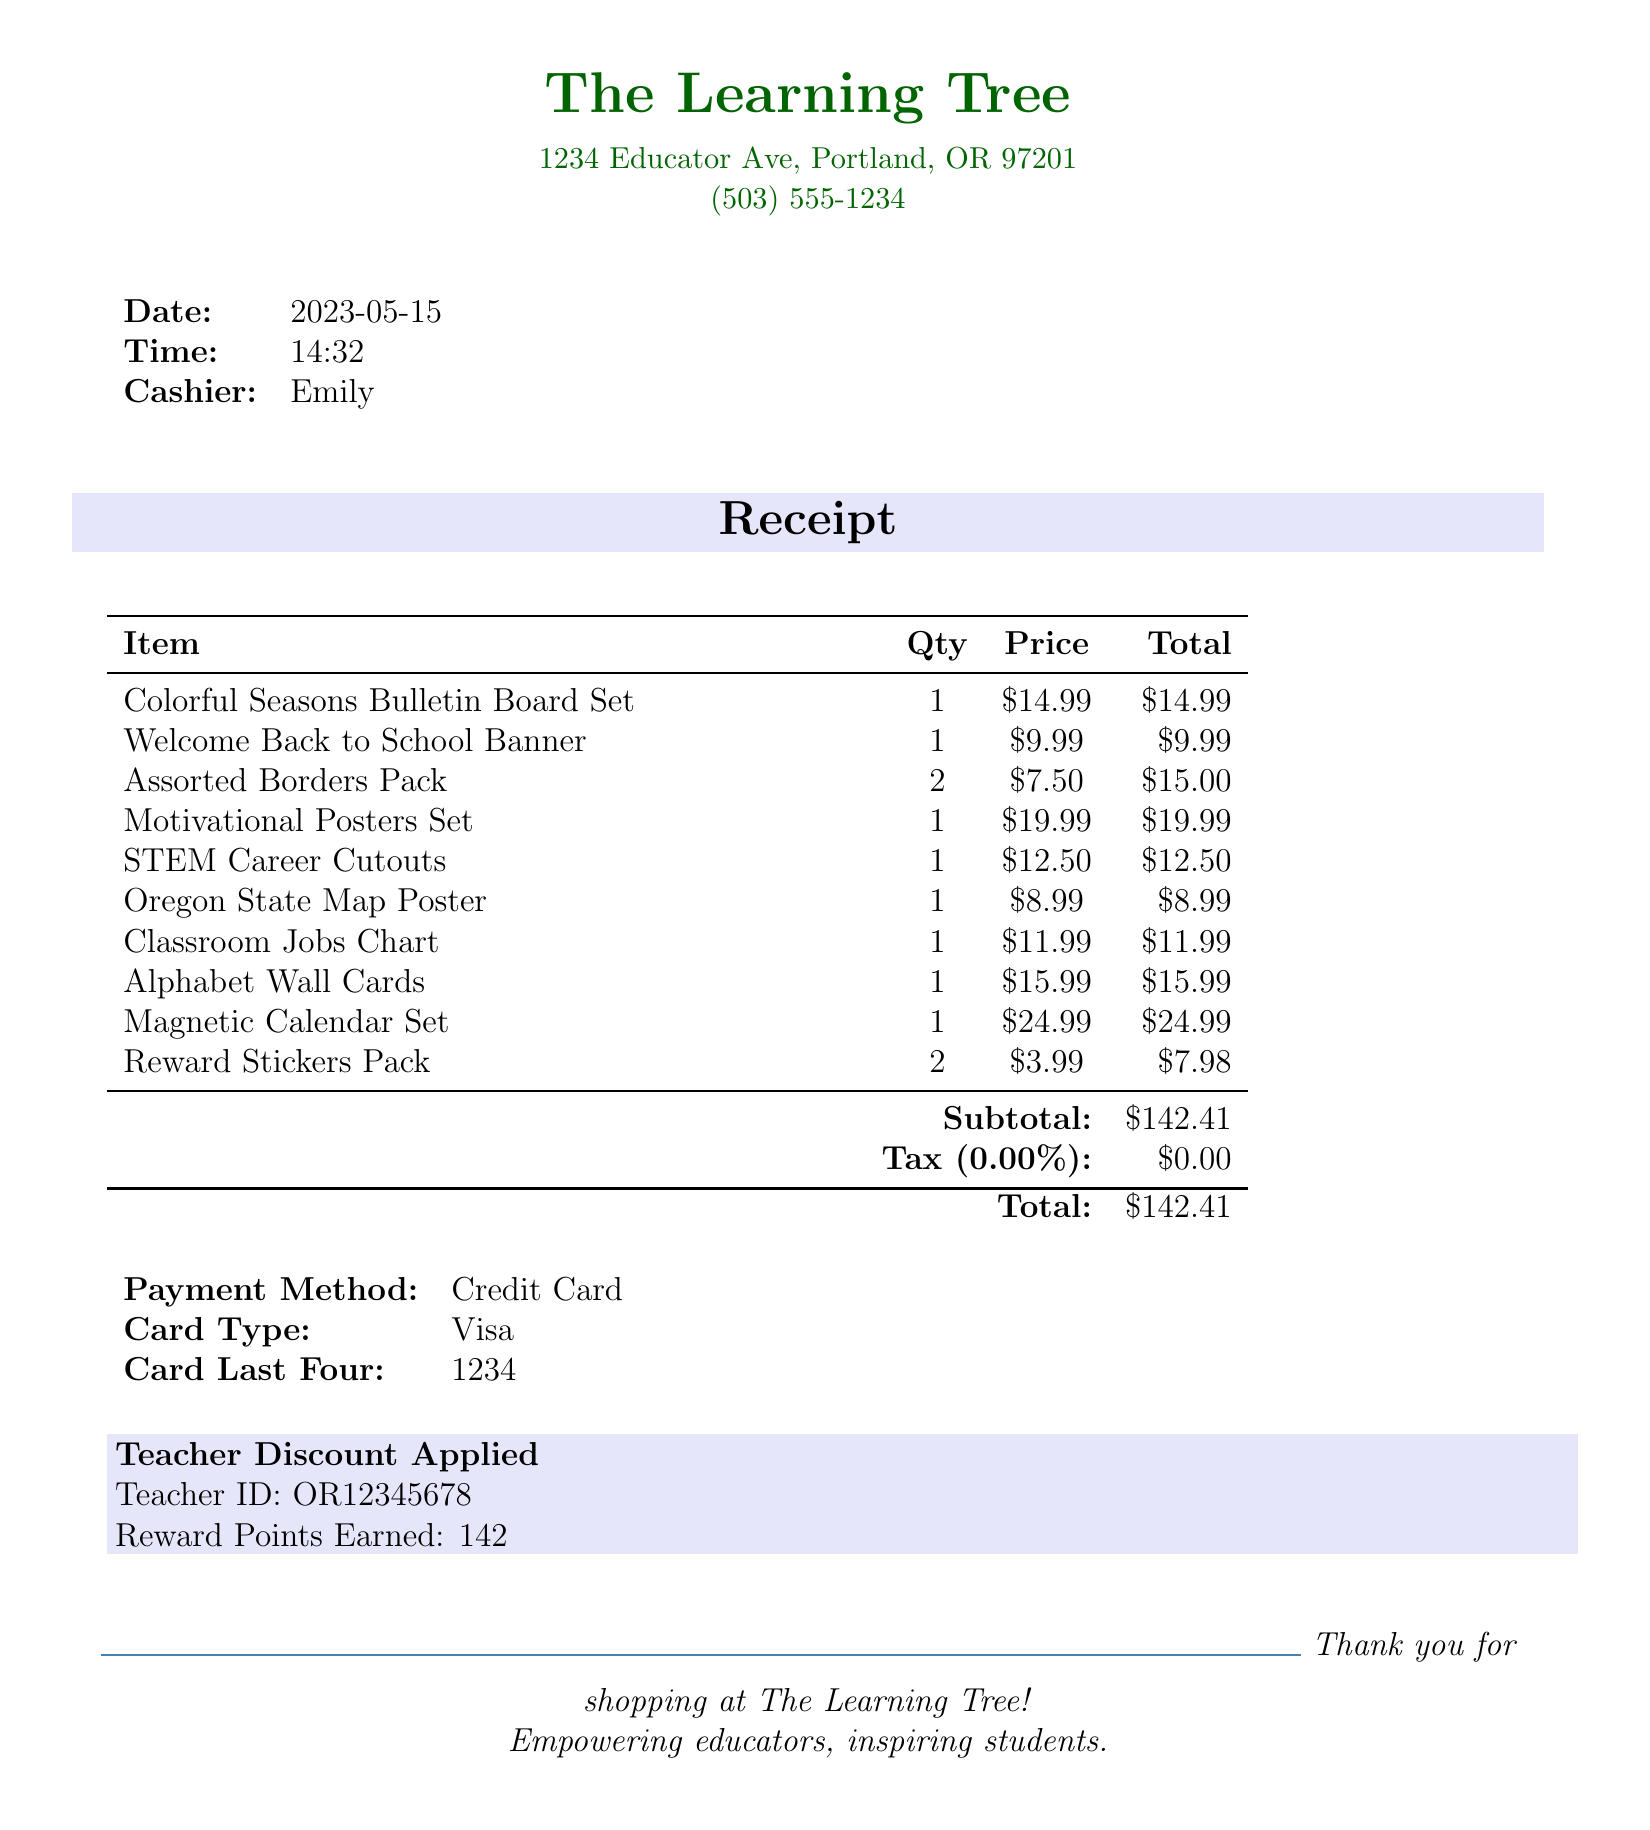What is the store name? The store name is clearly stated at the top of the receipt.
Answer: The Learning Tree What is the date of the transaction? The date of the transaction is noted in the document.
Answer: 2023-05-15 Who was the cashier? The cashier’s name is identified in the details of the transaction.
Answer: Emily What is the total amount spent? The total amount is provided at the end of the receipt summary.
Answer: 142.41 How many Assorted Borders Packs were purchased? The quantity of Assorted Borders Packs is listed next to the item name.
Answer: 2 What type of payment was used? The payment method is specified in the payment summary section.
Answer: Credit Card Was a teacher discount applied? The document explicitly states whether a teacher discount was applied or not.
Answer: Yes How many reward points were earned? The reward points earned are mentioned at the bottom of the receipt.
Answer: 142 What item has the highest price? The prices of the items can be compared to determine which is the highest.
Answer: Magnetic Calendar Set What is the card type used for payment? The type of card used for payment is specified in the payment details.
Answer: Visa 